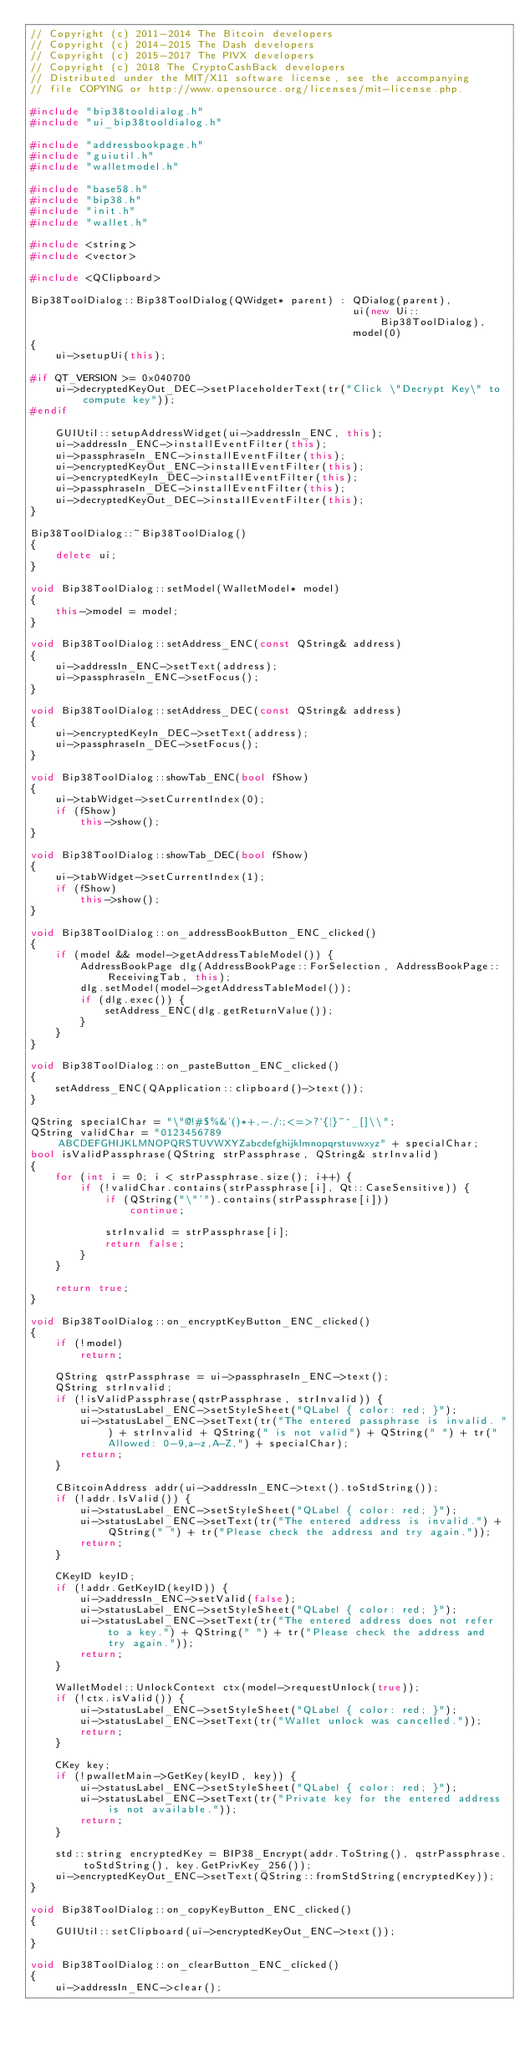Convert code to text. <code><loc_0><loc_0><loc_500><loc_500><_C++_>// Copyright (c) 2011-2014 The Bitcoin developers
// Copyright (c) 2014-2015 The Dash developers
// Copyright (c) 2015-2017 The PIVX developers 
// Copyright (c) 2018 The CryptoCashBack developers
// Distributed under the MIT/X11 software license, see the accompanying
// file COPYING or http://www.opensource.org/licenses/mit-license.php.

#include "bip38tooldialog.h"
#include "ui_bip38tooldialog.h"

#include "addressbookpage.h"
#include "guiutil.h"
#include "walletmodel.h"

#include "base58.h"
#include "bip38.h"
#include "init.h"
#include "wallet.h"

#include <string>
#include <vector>

#include <QClipboard>

Bip38ToolDialog::Bip38ToolDialog(QWidget* parent) : QDialog(parent),
                                                    ui(new Ui::Bip38ToolDialog),
                                                    model(0)
{
    ui->setupUi(this);

#if QT_VERSION >= 0x040700
    ui->decryptedKeyOut_DEC->setPlaceholderText(tr("Click \"Decrypt Key\" to compute key"));
#endif

    GUIUtil::setupAddressWidget(ui->addressIn_ENC, this);
    ui->addressIn_ENC->installEventFilter(this);
    ui->passphraseIn_ENC->installEventFilter(this);
    ui->encryptedKeyOut_ENC->installEventFilter(this);
    ui->encryptedKeyIn_DEC->installEventFilter(this);
    ui->passphraseIn_DEC->installEventFilter(this);
    ui->decryptedKeyOut_DEC->installEventFilter(this);
}

Bip38ToolDialog::~Bip38ToolDialog()
{
    delete ui;
}

void Bip38ToolDialog::setModel(WalletModel* model)
{
    this->model = model;
}

void Bip38ToolDialog::setAddress_ENC(const QString& address)
{
    ui->addressIn_ENC->setText(address);
    ui->passphraseIn_ENC->setFocus();
}

void Bip38ToolDialog::setAddress_DEC(const QString& address)
{
    ui->encryptedKeyIn_DEC->setText(address);
    ui->passphraseIn_DEC->setFocus();
}

void Bip38ToolDialog::showTab_ENC(bool fShow)
{
    ui->tabWidget->setCurrentIndex(0);
    if (fShow)
        this->show();
}

void Bip38ToolDialog::showTab_DEC(bool fShow)
{
    ui->tabWidget->setCurrentIndex(1);
    if (fShow)
        this->show();
}

void Bip38ToolDialog::on_addressBookButton_ENC_clicked()
{
    if (model && model->getAddressTableModel()) {
        AddressBookPage dlg(AddressBookPage::ForSelection, AddressBookPage::ReceivingTab, this);
        dlg.setModel(model->getAddressTableModel());
        if (dlg.exec()) {
            setAddress_ENC(dlg.getReturnValue());
        }
    }
}

void Bip38ToolDialog::on_pasteButton_ENC_clicked()
{
    setAddress_ENC(QApplication::clipboard()->text());
}

QString specialChar = "\"@!#$%&'()*+,-./:;<=>?`{|}~^_[]\\";
QString validChar = "0123456789ABCDEFGHIJKLMNOPQRSTUVWXYZabcdefghijklmnopqrstuvwxyz" + specialChar;
bool isValidPassphrase(QString strPassphrase, QString& strInvalid)
{
    for (int i = 0; i < strPassphrase.size(); i++) {
        if (!validChar.contains(strPassphrase[i], Qt::CaseSensitive)) {
            if (QString("\"'").contains(strPassphrase[i]))
                continue;

            strInvalid = strPassphrase[i];
            return false;
        }
    }

    return true;
}

void Bip38ToolDialog::on_encryptKeyButton_ENC_clicked()
{
    if (!model)
        return;

    QString qstrPassphrase = ui->passphraseIn_ENC->text();
    QString strInvalid;
    if (!isValidPassphrase(qstrPassphrase, strInvalid)) {
        ui->statusLabel_ENC->setStyleSheet("QLabel { color: red; }");
        ui->statusLabel_ENC->setText(tr("The entered passphrase is invalid. ") + strInvalid + QString(" is not valid") + QString(" ") + tr("Allowed: 0-9,a-z,A-Z,") + specialChar);
        return;
    }

    CBitcoinAddress addr(ui->addressIn_ENC->text().toStdString());
    if (!addr.IsValid()) {
        ui->statusLabel_ENC->setStyleSheet("QLabel { color: red; }");
        ui->statusLabel_ENC->setText(tr("The entered address is invalid.") + QString(" ") + tr("Please check the address and try again."));
        return;
    }

    CKeyID keyID;
    if (!addr.GetKeyID(keyID)) {
        ui->addressIn_ENC->setValid(false);
        ui->statusLabel_ENC->setStyleSheet("QLabel { color: red; }");
        ui->statusLabel_ENC->setText(tr("The entered address does not refer to a key.") + QString(" ") + tr("Please check the address and try again."));
        return;
    }

    WalletModel::UnlockContext ctx(model->requestUnlock(true));
    if (!ctx.isValid()) {
        ui->statusLabel_ENC->setStyleSheet("QLabel { color: red; }");
        ui->statusLabel_ENC->setText(tr("Wallet unlock was cancelled."));
        return;
    }

    CKey key;
    if (!pwalletMain->GetKey(keyID, key)) {
        ui->statusLabel_ENC->setStyleSheet("QLabel { color: red; }");
        ui->statusLabel_ENC->setText(tr("Private key for the entered address is not available."));
        return;
    }

    std::string encryptedKey = BIP38_Encrypt(addr.ToString(), qstrPassphrase.toStdString(), key.GetPrivKey_256());
    ui->encryptedKeyOut_ENC->setText(QString::fromStdString(encryptedKey));
}

void Bip38ToolDialog::on_copyKeyButton_ENC_clicked()
{
    GUIUtil::setClipboard(ui->encryptedKeyOut_ENC->text());
}

void Bip38ToolDialog::on_clearButton_ENC_clicked()
{
    ui->addressIn_ENC->clear();</code> 